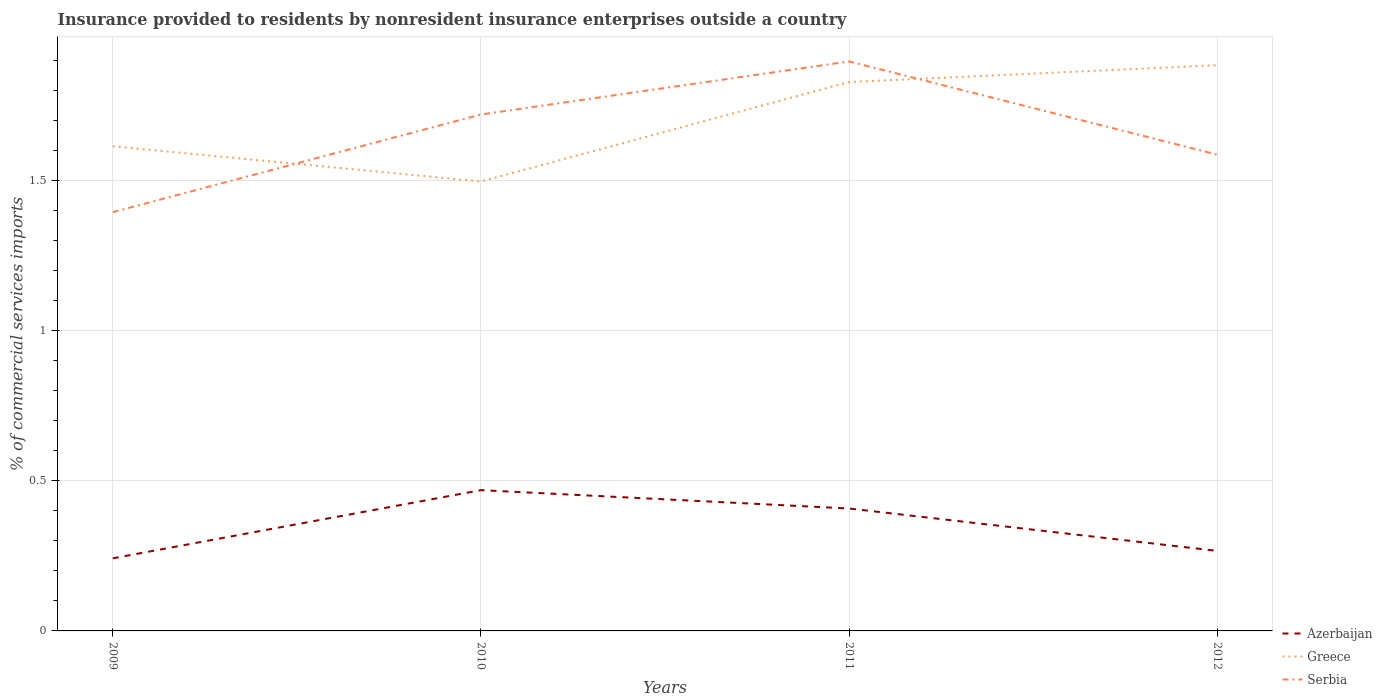How many different coloured lines are there?
Give a very brief answer. 3. Across all years, what is the maximum Insurance provided to residents in Greece?
Offer a very short reply. 1.5. In which year was the Insurance provided to residents in Azerbaijan maximum?
Keep it short and to the point. 2009. What is the total Insurance provided to residents in Azerbaijan in the graph?
Your response must be concise. 0.06. What is the difference between the highest and the second highest Insurance provided to residents in Serbia?
Offer a very short reply. 0.5. What is the difference between the highest and the lowest Insurance provided to residents in Serbia?
Give a very brief answer. 2. Is the Insurance provided to residents in Azerbaijan strictly greater than the Insurance provided to residents in Greece over the years?
Offer a very short reply. Yes. How many lines are there?
Provide a succinct answer. 3. Are the values on the major ticks of Y-axis written in scientific E-notation?
Your response must be concise. No. What is the title of the graph?
Your answer should be very brief. Insurance provided to residents by nonresident insurance enterprises outside a country. Does "Other small states" appear as one of the legend labels in the graph?
Give a very brief answer. No. What is the label or title of the X-axis?
Your response must be concise. Years. What is the label or title of the Y-axis?
Give a very brief answer. % of commercial services imports. What is the % of commercial services imports in Azerbaijan in 2009?
Your answer should be compact. 0.24. What is the % of commercial services imports of Greece in 2009?
Provide a succinct answer. 1.61. What is the % of commercial services imports in Serbia in 2009?
Make the answer very short. 1.39. What is the % of commercial services imports of Azerbaijan in 2010?
Provide a short and direct response. 0.47. What is the % of commercial services imports in Greece in 2010?
Your response must be concise. 1.5. What is the % of commercial services imports in Serbia in 2010?
Your response must be concise. 1.72. What is the % of commercial services imports of Azerbaijan in 2011?
Make the answer very short. 0.41. What is the % of commercial services imports of Greece in 2011?
Your answer should be very brief. 1.83. What is the % of commercial services imports in Serbia in 2011?
Give a very brief answer. 1.9. What is the % of commercial services imports in Azerbaijan in 2012?
Offer a very short reply. 0.27. What is the % of commercial services imports in Greece in 2012?
Keep it short and to the point. 1.88. What is the % of commercial services imports of Serbia in 2012?
Your answer should be very brief. 1.59. Across all years, what is the maximum % of commercial services imports in Azerbaijan?
Make the answer very short. 0.47. Across all years, what is the maximum % of commercial services imports of Greece?
Your answer should be compact. 1.88. Across all years, what is the maximum % of commercial services imports of Serbia?
Provide a short and direct response. 1.9. Across all years, what is the minimum % of commercial services imports in Azerbaijan?
Your answer should be very brief. 0.24. Across all years, what is the minimum % of commercial services imports of Greece?
Your response must be concise. 1.5. Across all years, what is the minimum % of commercial services imports of Serbia?
Ensure brevity in your answer.  1.39. What is the total % of commercial services imports of Azerbaijan in the graph?
Ensure brevity in your answer.  1.38. What is the total % of commercial services imports in Greece in the graph?
Provide a short and direct response. 6.82. What is the total % of commercial services imports of Serbia in the graph?
Keep it short and to the point. 6.59. What is the difference between the % of commercial services imports in Azerbaijan in 2009 and that in 2010?
Your answer should be compact. -0.23. What is the difference between the % of commercial services imports of Greece in 2009 and that in 2010?
Make the answer very short. 0.12. What is the difference between the % of commercial services imports in Serbia in 2009 and that in 2010?
Your answer should be compact. -0.33. What is the difference between the % of commercial services imports in Azerbaijan in 2009 and that in 2011?
Your response must be concise. -0.17. What is the difference between the % of commercial services imports in Greece in 2009 and that in 2011?
Offer a terse response. -0.21. What is the difference between the % of commercial services imports in Serbia in 2009 and that in 2011?
Your answer should be very brief. -0.5. What is the difference between the % of commercial services imports of Azerbaijan in 2009 and that in 2012?
Offer a very short reply. -0.02. What is the difference between the % of commercial services imports in Greece in 2009 and that in 2012?
Ensure brevity in your answer.  -0.27. What is the difference between the % of commercial services imports in Serbia in 2009 and that in 2012?
Provide a succinct answer. -0.19. What is the difference between the % of commercial services imports of Azerbaijan in 2010 and that in 2011?
Make the answer very short. 0.06. What is the difference between the % of commercial services imports in Greece in 2010 and that in 2011?
Offer a very short reply. -0.33. What is the difference between the % of commercial services imports of Serbia in 2010 and that in 2011?
Keep it short and to the point. -0.18. What is the difference between the % of commercial services imports of Azerbaijan in 2010 and that in 2012?
Your response must be concise. 0.2. What is the difference between the % of commercial services imports of Greece in 2010 and that in 2012?
Your response must be concise. -0.39. What is the difference between the % of commercial services imports of Serbia in 2010 and that in 2012?
Offer a very short reply. 0.13. What is the difference between the % of commercial services imports of Azerbaijan in 2011 and that in 2012?
Give a very brief answer. 0.14. What is the difference between the % of commercial services imports in Greece in 2011 and that in 2012?
Ensure brevity in your answer.  -0.06. What is the difference between the % of commercial services imports of Serbia in 2011 and that in 2012?
Your answer should be very brief. 0.31. What is the difference between the % of commercial services imports in Azerbaijan in 2009 and the % of commercial services imports in Greece in 2010?
Make the answer very short. -1.25. What is the difference between the % of commercial services imports in Azerbaijan in 2009 and the % of commercial services imports in Serbia in 2010?
Your answer should be compact. -1.48. What is the difference between the % of commercial services imports of Greece in 2009 and the % of commercial services imports of Serbia in 2010?
Give a very brief answer. -0.11. What is the difference between the % of commercial services imports of Azerbaijan in 2009 and the % of commercial services imports of Greece in 2011?
Make the answer very short. -1.59. What is the difference between the % of commercial services imports in Azerbaijan in 2009 and the % of commercial services imports in Serbia in 2011?
Make the answer very short. -1.65. What is the difference between the % of commercial services imports of Greece in 2009 and the % of commercial services imports of Serbia in 2011?
Your answer should be compact. -0.28. What is the difference between the % of commercial services imports in Azerbaijan in 2009 and the % of commercial services imports in Greece in 2012?
Offer a terse response. -1.64. What is the difference between the % of commercial services imports of Azerbaijan in 2009 and the % of commercial services imports of Serbia in 2012?
Offer a terse response. -1.34. What is the difference between the % of commercial services imports in Greece in 2009 and the % of commercial services imports in Serbia in 2012?
Ensure brevity in your answer.  0.03. What is the difference between the % of commercial services imports of Azerbaijan in 2010 and the % of commercial services imports of Greece in 2011?
Your answer should be very brief. -1.36. What is the difference between the % of commercial services imports in Azerbaijan in 2010 and the % of commercial services imports in Serbia in 2011?
Offer a terse response. -1.43. What is the difference between the % of commercial services imports in Greece in 2010 and the % of commercial services imports in Serbia in 2011?
Ensure brevity in your answer.  -0.4. What is the difference between the % of commercial services imports in Azerbaijan in 2010 and the % of commercial services imports in Greece in 2012?
Give a very brief answer. -1.41. What is the difference between the % of commercial services imports of Azerbaijan in 2010 and the % of commercial services imports of Serbia in 2012?
Offer a very short reply. -1.12. What is the difference between the % of commercial services imports of Greece in 2010 and the % of commercial services imports of Serbia in 2012?
Offer a very short reply. -0.09. What is the difference between the % of commercial services imports of Azerbaijan in 2011 and the % of commercial services imports of Greece in 2012?
Ensure brevity in your answer.  -1.48. What is the difference between the % of commercial services imports of Azerbaijan in 2011 and the % of commercial services imports of Serbia in 2012?
Provide a short and direct response. -1.18. What is the difference between the % of commercial services imports in Greece in 2011 and the % of commercial services imports in Serbia in 2012?
Offer a very short reply. 0.24. What is the average % of commercial services imports of Azerbaijan per year?
Your answer should be compact. 0.35. What is the average % of commercial services imports in Greece per year?
Make the answer very short. 1.7. What is the average % of commercial services imports of Serbia per year?
Your answer should be compact. 1.65. In the year 2009, what is the difference between the % of commercial services imports of Azerbaijan and % of commercial services imports of Greece?
Keep it short and to the point. -1.37. In the year 2009, what is the difference between the % of commercial services imports in Azerbaijan and % of commercial services imports in Serbia?
Provide a succinct answer. -1.15. In the year 2009, what is the difference between the % of commercial services imports in Greece and % of commercial services imports in Serbia?
Keep it short and to the point. 0.22. In the year 2010, what is the difference between the % of commercial services imports in Azerbaijan and % of commercial services imports in Greece?
Offer a terse response. -1.03. In the year 2010, what is the difference between the % of commercial services imports in Azerbaijan and % of commercial services imports in Serbia?
Make the answer very short. -1.25. In the year 2010, what is the difference between the % of commercial services imports of Greece and % of commercial services imports of Serbia?
Provide a short and direct response. -0.22. In the year 2011, what is the difference between the % of commercial services imports in Azerbaijan and % of commercial services imports in Greece?
Make the answer very short. -1.42. In the year 2011, what is the difference between the % of commercial services imports in Azerbaijan and % of commercial services imports in Serbia?
Make the answer very short. -1.49. In the year 2011, what is the difference between the % of commercial services imports in Greece and % of commercial services imports in Serbia?
Your answer should be compact. -0.07. In the year 2012, what is the difference between the % of commercial services imports of Azerbaijan and % of commercial services imports of Greece?
Keep it short and to the point. -1.62. In the year 2012, what is the difference between the % of commercial services imports in Azerbaijan and % of commercial services imports in Serbia?
Make the answer very short. -1.32. In the year 2012, what is the difference between the % of commercial services imports of Greece and % of commercial services imports of Serbia?
Make the answer very short. 0.3. What is the ratio of the % of commercial services imports of Azerbaijan in 2009 to that in 2010?
Provide a short and direct response. 0.52. What is the ratio of the % of commercial services imports in Greece in 2009 to that in 2010?
Provide a succinct answer. 1.08. What is the ratio of the % of commercial services imports in Serbia in 2009 to that in 2010?
Your answer should be very brief. 0.81. What is the ratio of the % of commercial services imports in Azerbaijan in 2009 to that in 2011?
Ensure brevity in your answer.  0.59. What is the ratio of the % of commercial services imports of Greece in 2009 to that in 2011?
Your response must be concise. 0.88. What is the ratio of the % of commercial services imports in Serbia in 2009 to that in 2011?
Offer a terse response. 0.74. What is the ratio of the % of commercial services imports of Azerbaijan in 2009 to that in 2012?
Your response must be concise. 0.91. What is the ratio of the % of commercial services imports in Greece in 2009 to that in 2012?
Make the answer very short. 0.86. What is the ratio of the % of commercial services imports in Serbia in 2009 to that in 2012?
Keep it short and to the point. 0.88. What is the ratio of the % of commercial services imports of Azerbaijan in 2010 to that in 2011?
Keep it short and to the point. 1.15. What is the ratio of the % of commercial services imports in Greece in 2010 to that in 2011?
Provide a short and direct response. 0.82. What is the ratio of the % of commercial services imports of Serbia in 2010 to that in 2011?
Keep it short and to the point. 0.91. What is the ratio of the % of commercial services imports in Azerbaijan in 2010 to that in 2012?
Provide a succinct answer. 1.76. What is the ratio of the % of commercial services imports of Greece in 2010 to that in 2012?
Your answer should be compact. 0.79. What is the ratio of the % of commercial services imports in Serbia in 2010 to that in 2012?
Provide a succinct answer. 1.08. What is the ratio of the % of commercial services imports of Azerbaijan in 2011 to that in 2012?
Keep it short and to the point. 1.53. What is the ratio of the % of commercial services imports of Greece in 2011 to that in 2012?
Make the answer very short. 0.97. What is the ratio of the % of commercial services imports in Serbia in 2011 to that in 2012?
Make the answer very short. 1.2. What is the difference between the highest and the second highest % of commercial services imports in Azerbaijan?
Offer a terse response. 0.06. What is the difference between the highest and the second highest % of commercial services imports in Greece?
Keep it short and to the point. 0.06. What is the difference between the highest and the second highest % of commercial services imports in Serbia?
Your answer should be compact. 0.18. What is the difference between the highest and the lowest % of commercial services imports in Azerbaijan?
Provide a succinct answer. 0.23. What is the difference between the highest and the lowest % of commercial services imports of Greece?
Your answer should be very brief. 0.39. What is the difference between the highest and the lowest % of commercial services imports in Serbia?
Keep it short and to the point. 0.5. 